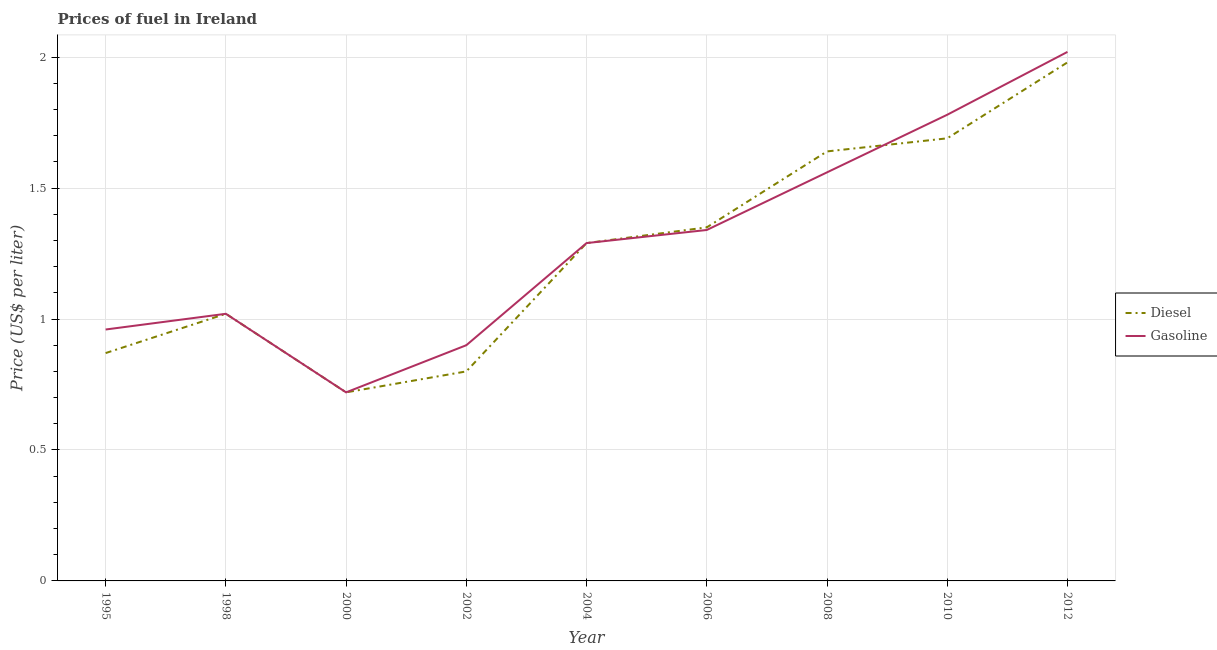What is the diesel price in 1998?
Offer a terse response. 1.02. Across all years, what is the maximum diesel price?
Provide a succinct answer. 1.98. Across all years, what is the minimum diesel price?
Your answer should be compact. 0.72. In which year was the diesel price maximum?
Give a very brief answer. 2012. In which year was the diesel price minimum?
Make the answer very short. 2000. What is the total gasoline price in the graph?
Your answer should be compact. 11.59. What is the difference between the diesel price in 1995 and that in 1998?
Ensure brevity in your answer.  -0.15. What is the difference between the diesel price in 2002 and the gasoline price in 1995?
Make the answer very short. -0.16. What is the average gasoline price per year?
Your answer should be compact. 1.29. In the year 1998, what is the difference between the diesel price and gasoline price?
Ensure brevity in your answer.  0. What is the ratio of the diesel price in 2006 to that in 2012?
Offer a terse response. 0.68. What is the difference between the highest and the second highest gasoline price?
Provide a succinct answer. 0.24. In how many years, is the gasoline price greater than the average gasoline price taken over all years?
Offer a terse response. 5. Does the gasoline price monotonically increase over the years?
Give a very brief answer. No. Is the gasoline price strictly less than the diesel price over the years?
Keep it short and to the point. No. How many years are there in the graph?
Offer a terse response. 9. Are the values on the major ticks of Y-axis written in scientific E-notation?
Your answer should be compact. No. How many legend labels are there?
Keep it short and to the point. 2. What is the title of the graph?
Offer a very short reply. Prices of fuel in Ireland. Does "National Visitors" appear as one of the legend labels in the graph?
Provide a succinct answer. No. What is the label or title of the Y-axis?
Keep it short and to the point. Price (US$ per liter). What is the Price (US$ per liter) in Diesel in 1995?
Provide a short and direct response. 0.87. What is the Price (US$ per liter) of Gasoline in 1995?
Keep it short and to the point. 0.96. What is the Price (US$ per liter) in Gasoline in 1998?
Provide a succinct answer. 1.02. What is the Price (US$ per liter) of Diesel in 2000?
Give a very brief answer. 0.72. What is the Price (US$ per liter) of Gasoline in 2000?
Keep it short and to the point. 0.72. What is the Price (US$ per liter) in Gasoline in 2002?
Give a very brief answer. 0.9. What is the Price (US$ per liter) of Diesel in 2004?
Offer a terse response. 1.29. What is the Price (US$ per liter) of Gasoline in 2004?
Give a very brief answer. 1.29. What is the Price (US$ per liter) of Diesel in 2006?
Your response must be concise. 1.35. What is the Price (US$ per liter) in Gasoline in 2006?
Offer a very short reply. 1.34. What is the Price (US$ per liter) in Diesel in 2008?
Offer a very short reply. 1.64. What is the Price (US$ per liter) in Gasoline in 2008?
Give a very brief answer. 1.56. What is the Price (US$ per liter) in Diesel in 2010?
Provide a succinct answer. 1.69. What is the Price (US$ per liter) in Gasoline in 2010?
Offer a terse response. 1.78. What is the Price (US$ per liter) of Diesel in 2012?
Keep it short and to the point. 1.98. What is the Price (US$ per liter) of Gasoline in 2012?
Your response must be concise. 2.02. Across all years, what is the maximum Price (US$ per liter) of Diesel?
Your response must be concise. 1.98. Across all years, what is the maximum Price (US$ per liter) in Gasoline?
Keep it short and to the point. 2.02. Across all years, what is the minimum Price (US$ per liter) of Diesel?
Offer a terse response. 0.72. Across all years, what is the minimum Price (US$ per liter) in Gasoline?
Give a very brief answer. 0.72. What is the total Price (US$ per liter) in Diesel in the graph?
Your response must be concise. 11.36. What is the total Price (US$ per liter) in Gasoline in the graph?
Your response must be concise. 11.59. What is the difference between the Price (US$ per liter) in Diesel in 1995 and that in 1998?
Make the answer very short. -0.15. What is the difference between the Price (US$ per liter) in Gasoline in 1995 and that in 1998?
Make the answer very short. -0.06. What is the difference between the Price (US$ per liter) of Gasoline in 1995 and that in 2000?
Offer a very short reply. 0.24. What is the difference between the Price (US$ per liter) in Diesel in 1995 and that in 2002?
Provide a short and direct response. 0.07. What is the difference between the Price (US$ per liter) in Diesel in 1995 and that in 2004?
Provide a succinct answer. -0.42. What is the difference between the Price (US$ per liter) of Gasoline in 1995 and that in 2004?
Give a very brief answer. -0.33. What is the difference between the Price (US$ per liter) of Diesel in 1995 and that in 2006?
Offer a terse response. -0.48. What is the difference between the Price (US$ per liter) in Gasoline in 1995 and that in 2006?
Make the answer very short. -0.38. What is the difference between the Price (US$ per liter) in Diesel in 1995 and that in 2008?
Give a very brief answer. -0.77. What is the difference between the Price (US$ per liter) of Gasoline in 1995 and that in 2008?
Provide a succinct answer. -0.6. What is the difference between the Price (US$ per liter) of Diesel in 1995 and that in 2010?
Your answer should be compact. -0.82. What is the difference between the Price (US$ per liter) of Gasoline in 1995 and that in 2010?
Give a very brief answer. -0.82. What is the difference between the Price (US$ per liter) in Diesel in 1995 and that in 2012?
Provide a succinct answer. -1.11. What is the difference between the Price (US$ per liter) of Gasoline in 1995 and that in 2012?
Offer a terse response. -1.06. What is the difference between the Price (US$ per liter) in Gasoline in 1998 and that in 2000?
Your answer should be compact. 0.3. What is the difference between the Price (US$ per liter) in Diesel in 1998 and that in 2002?
Provide a short and direct response. 0.22. What is the difference between the Price (US$ per liter) of Gasoline in 1998 and that in 2002?
Your response must be concise. 0.12. What is the difference between the Price (US$ per liter) in Diesel in 1998 and that in 2004?
Your answer should be compact. -0.27. What is the difference between the Price (US$ per liter) in Gasoline in 1998 and that in 2004?
Offer a terse response. -0.27. What is the difference between the Price (US$ per liter) in Diesel in 1998 and that in 2006?
Make the answer very short. -0.33. What is the difference between the Price (US$ per liter) in Gasoline in 1998 and that in 2006?
Make the answer very short. -0.32. What is the difference between the Price (US$ per liter) of Diesel in 1998 and that in 2008?
Offer a terse response. -0.62. What is the difference between the Price (US$ per liter) in Gasoline in 1998 and that in 2008?
Your answer should be very brief. -0.54. What is the difference between the Price (US$ per liter) of Diesel in 1998 and that in 2010?
Provide a succinct answer. -0.67. What is the difference between the Price (US$ per liter) of Gasoline in 1998 and that in 2010?
Offer a very short reply. -0.76. What is the difference between the Price (US$ per liter) of Diesel in 1998 and that in 2012?
Offer a terse response. -0.96. What is the difference between the Price (US$ per liter) in Gasoline in 1998 and that in 2012?
Provide a succinct answer. -1. What is the difference between the Price (US$ per liter) in Diesel in 2000 and that in 2002?
Offer a terse response. -0.08. What is the difference between the Price (US$ per liter) in Gasoline in 2000 and that in 2002?
Your response must be concise. -0.18. What is the difference between the Price (US$ per liter) in Diesel in 2000 and that in 2004?
Provide a short and direct response. -0.57. What is the difference between the Price (US$ per liter) in Gasoline in 2000 and that in 2004?
Your response must be concise. -0.57. What is the difference between the Price (US$ per liter) in Diesel in 2000 and that in 2006?
Offer a very short reply. -0.63. What is the difference between the Price (US$ per liter) in Gasoline in 2000 and that in 2006?
Make the answer very short. -0.62. What is the difference between the Price (US$ per liter) in Diesel in 2000 and that in 2008?
Your answer should be very brief. -0.92. What is the difference between the Price (US$ per liter) in Gasoline in 2000 and that in 2008?
Give a very brief answer. -0.84. What is the difference between the Price (US$ per liter) of Diesel in 2000 and that in 2010?
Your answer should be compact. -0.97. What is the difference between the Price (US$ per liter) of Gasoline in 2000 and that in 2010?
Your answer should be very brief. -1.06. What is the difference between the Price (US$ per liter) in Diesel in 2000 and that in 2012?
Your answer should be very brief. -1.26. What is the difference between the Price (US$ per liter) in Diesel in 2002 and that in 2004?
Your answer should be compact. -0.49. What is the difference between the Price (US$ per liter) in Gasoline in 2002 and that in 2004?
Provide a short and direct response. -0.39. What is the difference between the Price (US$ per liter) in Diesel in 2002 and that in 2006?
Your answer should be very brief. -0.55. What is the difference between the Price (US$ per liter) of Gasoline in 2002 and that in 2006?
Give a very brief answer. -0.44. What is the difference between the Price (US$ per liter) of Diesel in 2002 and that in 2008?
Make the answer very short. -0.84. What is the difference between the Price (US$ per liter) of Gasoline in 2002 and that in 2008?
Make the answer very short. -0.66. What is the difference between the Price (US$ per liter) in Diesel in 2002 and that in 2010?
Give a very brief answer. -0.89. What is the difference between the Price (US$ per liter) of Gasoline in 2002 and that in 2010?
Your answer should be very brief. -0.88. What is the difference between the Price (US$ per liter) of Diesel in 2002 and that in 2012?
Offer a very short reply. -1.18. What is the difference between the Price (US$ per liter) of Gasoline in 2002 and that in 2012?
Your answer should be compact. -1.12. What is the difference between the Price (US$ per liter) of Diesel in 2004 and that in 2006?
Make the answer very short. -0.06. What is the difference between the Price (US$ per liter) in Gasoline in 2004 and that in 2006?
Make the answer very short. -0.05. What is the difference between the Price (US$ per liter) in Diesel in 2004 and that in 2008?
Your answer should be very brief. -0.35. What is the difference between the Price (US$ per liter) in Gasoline in 2004 and that in 2008?
Make the answer very short. -0.27. What is the difference between the Price (US$ per liter) of Gasoline in 2004 and that in 2010?
Offer a very short reply. -0.49. What is the difference between the Price (US$ per liter) of Diesel in 2004 and that in 2012?
Your answer should be compact. -0.69. What is the difference between the Price (US$ per liter) in Gasoline in 2004 and that in 2012?
Your answer should be compact. -0.73. What is the difference between the Price (US$ per liter) in Diesel in 2006 and that in 2008?
Make the answer very short. -0.29. What is the difference between the Price (US$ per liter) in Gasoline in 2006 and that in 2008?
Your answer should be very brief. -0.22. What is the difference between the Price (US$ per liter) of Diesel in 2006 and that in 2010?
Provide a succinct answer. -0.34. What is the difference between the Price (US$ per liter) of Gasoline in 2006 and that in 2010?
Give a very brief answer. -0.44. What is the difference between the Price (US$ per liter) of Diesel in 2006 and that in 2012?
Ensure brevity in your answer.  -0.63. What is the difference between the Price (US$ per liter) of Gasoline in 2006 and that in 2012?
Provide a short and direct response. -0.68. What is the difference between the Price (US$ per liter) in Diesel in 2008 and that in 2010?
Give a very brief answer. -0.05. What is the difference between the Price (US$ per liter) in Gasoline in 2008 and that in 2010?
Offer a terse response. -0.22. What is the difference between the Price (US$ per liter) of Diesel in 2008 and that in 2012?
Provide a succinct answer. -0.34. What is the difference between the Price (US$ per liter) in Gasoline in 2008 and that in 2012?
Your answer should be compact. -0.46. What is the difference between the Price (US$ per liter) of Diesel in 2010 and that in 2012?
Your answer should be compact. -0.29. What is the difference between the Price (US$ per liter) in Gasoline in 2010 and that in 2012?
Keep it short and to the point. -0.24. What is the difference between the Price (US$ per liter) of Diesel in 1995 and the Price (US$ per liter) of Gasoline in 1998?
Ensure brevity in your answer.  -0.15. What is the difference between the Price (US$ per liter) of Diesel in 1995 and the Price (US$ per liter) of Gasoline in 2002?
Make the answer very short. -0.03. What is the difference between the Price (US$ per liter) in Diesel in 1995 and the Price (US$ per liter) in Gasoline in 2004?
Offer a very short reply. -0.42. What is the difference between the Price (US$ per liter) in Diesel in 1995 and the Price (US$ per liter) in Gasoline in 2006?
Keep it short and to the point. -0.47. What is the difference between the Price (US$ per liter) of Diesel in 1995 and the Price (US$ per liter) of Gasoline in 2008?
Make the answer very short. -0.69. What is the difference between the Price (US$ per liter) in Diesel in 1995 and the Price (US$ per liter) in Gasoline in 2010?
Ensure brevity in your answer.  -0.91. What is the difference between the Price (US$ per liter) of Diesel in 1995 and the Price (US$ per liter) of Gasoline in 2012?
Offer a very short reply. -1.15. What is the difference between the Price (US$ per liter) in Diesel in 1998 and the Price (US$ per liter) in Gasoline in 2002?
Offer a very short reply. 0.12. What is the difference between the Price (US$ per liter) in Diesel in 1998 and the Price (US$ per liter) in Gasoline in 2004?
Provide a short and direct response. -0.27. What is the difference between the Price (US$ per liter) in Diesel in 1998 and the Price (US$ per liter) in Gasoline in 2006?
Give a very brief answer. -0.32. What is the difference between the Price (US$ per liter) in Diesel in 1998 and the Price (US$ per liter) in Gasoline in 2008?
Offer a terse response. -0.54. What is the difference between the Price (US$ per liter) of Diesel in 1998 and the Price (US$ per liter) of Gasoline in 2010?
Your response must be concise. -0.76. What is the difference between the Price (US$ per liter) of Diesel in 1998 and the Price (US$ per liter) of Gasoline in 2012?
Offer a terse response. -1. What is the difference between the Price (US$ per liter) in Diesel in 2000 and the Price (US$ per liter) in Gasoline in 2002?
Provide a succinct answer. -0.18. What is the difference between the Price (US$ per liter) of Diesel in 2000 and the Price (US$ per liter) of Gasoline in 2004?
Your response must be concise. -0.57. What is the difference between the Price (US$ per liter) in Diesel in 2000 and the Price (US$ per liter) in Gasoline in 2006?
Offer a very short reply. -0.62. What is the difference between the Price (US$ per liter) in Diesel in 2000 and the Price (US$ per liter) in Gasoline in 2008?
Ensure brevity in your answer.  -0.84. What is the difference between the Price (US$ per liter) in Diesel in 2000 and the Price (US$ per liter) in Gasoline in 2010?
Provide a short and direct response. -1.06. What is the difference between the Price (US$ per liter) in Diesel in 2002 and the Price (US$ per liter) in Gasoline in 2004?
Give a very brief answer. -0.49. What is the difference between the Price (US$ per liter) of Diesel in 2002 and the Price (US$ per liter) of Gasoline in 2006?
Your answer should be compact. -0.54. What is the difference between the Price (US$ per liter) of Diesel in 2002 and the Price (US$ per liter) of Gasoline in 2008?
Keep it short and to the point. -0.76. What is the difference between the Price (US$ per liter) in Diesel in 2002 and the Price (US$ per liter) in Gasoline in 2010?
Ensure brevity in your answer.  -0.98. What is the difference between the Price (US$ per liter) in Diesel in 2002 and the Price (US$ per liter) in Gasoline in 2012?
Keep it short and to the point. -1.22. What is the difference between the Price (US$ per liter) of Diesel in 2004 and the Price (US$ per liter) of Gasoline in 2006?
Your response must be concise. -0.05. What is the difference between the Price (US$ per liter) of Diesel in 2004 and the Price (US$ per liter) of Gasoline in 2008?
Your response must be concise. -0.27. What is the difference between the Price (US$ per liter) of Diesel in 2004 and the Price (US$ per liter) of Gasoline in 2010?
Give a very brief answer. -0.49. What is the difference between the Price (US$ per liter) in Diesel in 2004 and the Price (US$ per liter) in Gasoline in 2012?
Offer a very short reply. -0.73. What is the difference between the Price (US$ per liter) of Diesel in 2006 and the Price (US$ per liter) of Gasoline in 2008?
Offer a very short reply. -0.21. What is the difference between the Price (US$ per liter) in Diesel in 2006 and the Price (US$ per liter) in Gasoline in 2010?
Your answer should be very brief. -0.43. What is the difference between the Price (US$ per liter) in Diesel in 2006 and the Price (US$ per liter) in Gasoline in 2012?
Keep it short and to the point. -0.67. What is the difference between the Price (US$ per liter) in Diesel in 2008 and the Price (US$ per liter) in Gasoline in 2010?
Keep it short and to the point. -0.14. What is the difference between the Price (US$ per liter) in Diesel in 2008 and the Price (US$ per liter) in Gasoline in 2012?
Offer a terse response. -0.38. What is the difference between the Price (US$ per liter) in Diesel in 2010 and the Price (US$ per liter) in Gasoline in 2012?
Ensure brevity in your answer.  -0.33. What is the average Price (US$ per liter) of Diesel per year?
Provide a short and direct response. 1.26. What is the average Price (US$ per liter) of Gasoline per year?
Provide a succinct answer. 1.29. In the year 1995, what is the difference between the Price (US$ per liter) of Diesel and Price (US$ per liter) of Gasoline?
Provide a succinct answer. -0.09. In the year 2000, what is the difference between the Price (US$ per liter) of Diesel and Price (US$ per liter) of Gasoline?
Ensure brevity in your answer.  0. In the year 2006, what is the difference between the Price (US$ per liter) in Diesel and Price (US$ per liter) in Gasoline?
Keep it short and to the point. 0.01. In the year 2010, what is the difference between the Price (US$ per liter) in Diesel and Price (US$ per liter) in Gasoline?
Offer a very short reply. -0.09. In the year 2012, what is the difference between the Price (US$ per liter) of Diesel and Price (US$ per liter) of Gasoline?
Make the answer very short. -0.04. What is the ratio of the Price (US$ per liter) in Diesel in 1995 to that in 1998?
Offer a very short reply. 0.85. What is the ratio of the Price (US$ per liter) of Diesel in 1995 to that in 2000?
Keep it short and to the point. 1.21. What is the ratio of the Price (US$ per liter) in Gasoline in 1995 to that in 2000?
Keep it short and to the point. 1.33. What is the ratio of the Price (US$ per liter) in Diesel in 1995 to that in 2002?
Your response must be concise. 1.09. What is the ratio of the Price (US$ per liter) of Gasoline in 1995 to that in 2002?
Your answer should be compact. 1.07. What is the ratio of the Price (US$ per liter) in Diesel in 1995 to that in 2004?
Provide a succinct answer. 0.67. What is the ratio of the Price (US$ per liter) of Gasoline in 1995 to that in 2004?
Make the answer very short. 0.74. What is the ratio of the Price (US$ per liter) of Diesel in 1995 to that in 2006?
Your answer should be very brief. 0.64. What is the ratio of the Price (US$ per liter) of Gasoline in 1995 to that in 2006?
Keep it short and to the point. 0.72. What is the ratio of the Price (US$ per liter) of Diesel in 1995 to that in 2008?
Your response must be concise. 0.53. What is the ratio of the Price (US$ per liter) in Gasoline in 1995 to that in 2008?
Give a very brief answer. 0.62. What is the ratio of the Price (US$ per liter) in Diesel in 1995 to that in 2010?
Offer a very short reply. 0.51. What is the ratio of the Price (US$ per liter) in Gasoline in 1995 to that in 2010?
Keep it short and to the point. 0.54. What is the ratio of the Price (US$ per liter) of Diesel in 1995 to that in 2012?
Your answer should be compact. 0.44. What is the ratio of the Price (US$ per liter) in Gasoline in 1995 to that in 2012?
Your answer should be compact. 0.48. What is the ratio of the Price (US$ per liter) in Diesel in 1998 to that in 2000?
Ensure brevity in your answer.  1.42. What is the ratio of the Price (US$ per liter) in Gasoline in 1998 to that in 2000?
Your response must be concise. 1.42. What is the ratio of the Price (US$ per liter) of Diesel in 1998 to that in 2002?
Your answer should be compact. 1.27. What is the ratio of the Price (US$ per liter) in Gasoline in 1998 to that in 2002?
Give a very brief answer. 1.13. What is the ratio of the Price (US$ per liter) of Diesel in 1998 to that in 2004?
Provide a succinct answer. 0.79. What is the ratio of the Price (US$ per liter) of Gasoline in 1998 to that in 2004?
Offer a terse response. 0.79. What is the ratio of the Price (US$ per liter) in Diesel in 1998 to that in 2006?
Offer a very short reply. 0.76. What is the ratio of the Price (US$ per liter) in Gasoline in 1998 to that in 2006?
Make the answer very short. 0.76. What is the ratio of the Price (US$ per liter) of Diesel in 1998 to that in 2008?
Your response must be concise. 0.62. What is the ratio of the Price (US$ per liter) in Gasoline in 1998 to that in 2008?
Your answer should be very brief. 0.65. What is the ratio of the Price (US$ per liter) in Diesel in 1998 to that in 2010?
Offer a very short reply. 0.6. What is the ratio of the Price (US$ per liter) in Gasoline in 1998 to that in 2010?
Offer a very short reply. 0.57. What is the ratio of the Price (US$ per liter) in Diesel in 1998 to that in 2012?
Your answer should be compact. 0.52. What is the ratio of the Price (US$ per liter) in Gasoline in 1998 to that in 2012?
Make the answer very short. 0.51. What is the ratio of the Price (US$ per liter) in Diesel in 2000 to that in 2002?
Offer a very short reply. 0.9. What is the ratio of the Price (US$ per liter) of Gasoline in 2000 to that in 2002?
Ensure brevity in your answer.  0.8. What is the ratio of the Price (US$ per liter) in Diesel in 2000 to that in 2004?
Provide a succinct answer. 0.56. What is the ratio of the Price (US$ per liter) in Gasoline in 2000 to that in 2004?
Ensure brevity in your answer.  0.56. What is the ratio of the Price (US$ per liter) in Diesel in 2000 to that in 2006?
Give a very brief answer. 0.53. What is the ratio of the Price (US$ per liter) in Gasoline in 2000 to that in 2006?
Your answer should be compact. 0.54. What is the ratio of the Price (US$ per liter) of Diesel in 2000 to that in 2008?
Provide a short and direct response. 0.44. What is the ratio of the Price (US$ per liter) in Gasoline in 2000 to that in 2008?
Your answer should be compact. 0.46. What is the ratio of the Price (US$ per liter) in Diesel in 2000 to that in 2010?
Your response must be concise. 0.43. What is the ratio of the Price (US$ per liter) in Gasoline in 2000 to that in 2010?
Offer a very short reply. 0.4. What is the ratio of the Price (US$ per liter) in Diesel in 2000 to that in 2012?
Offer a terse response. 0.36. What is the ratio of the Price (US$ per liter) of Gasoline in 2000 to that in 2012?
Your answer should be compact. 0.36. What is the ratio of the Price (US$ per liter) of Diesel in 2002 to that in 2004?
Your answer should be very brief. 0.62. What is the ratio of the Price (US$ per liter) of Gasoline in 2002 to that in 2004?
Offer a very short reply. 0.7. What is the ratio of the Price (US$ per liter) in Diesel in 2002 to that in 2006?
Provide a succinct answer. 0.59. What is the ratio of the Price (US$ per liter) in Gasoline in 2002 to that in 2006?
Offer a terse response. 0.67. What is the ratio of the Price (US$ per liter) in Diesel in 2002 to that in 2008?
Provide a succinct answer. 0.49. What is the ratio of the Price (US$ per liter) of Gasoline in 2002 to that in 2008?
Your response must be concise. 0.58. What is the ratio of the Price (US$ per liter) of Diesel in 2002 to that in 2010?
Give a very brief answer. 0.47. What is the ratio of the Price (US$ per liter) in Gasoline in 2002 to that in 2010?
Keep it short and to the point. 0.51. What is the ratio of the Price (US$ per liter) in Diesel in 2002 to that in 2012?
Your answer should be compact. 0.4. What is the ratio of the Price (US$ per liter) of Gasoline in 2002 to that in 2012?
Give a very brief answer. 0.45. What is the ratio of the Price (US$ per liter) in Diesel in 2004 to that in 2006?
Your answer should be compact. 0.96. What is the ratio of the Price (US$ per liter) in Gasoline in 2004 to that in 2006?
Your answer should be compact. 0.96. What is the ratio of the Price (US$ per liter) of Diesel in 2004 to that in 2008?
Offer a very short reply. 0.79. What is the ratio of the Price (US$ per liter) in Gasoline in 2004 to that in 2008?
Ensure brevity in your answer.  0.83. What is the ratio of the Price (US$ per liter) of Diesel in 2004 to that in 2010?
Provide a succinct answer. 0.76. What is the ratio of the Price (US$ per liter) in Gasoline in 2004 to that in 2010?
Provide a succinct answer. 0.72. What is the ratio of the Price (US$ per liter) in Diesel in 2004 to that in 2012?
Keep it short and to the point. 0.65. What is the ratio of the Price (US$ per liter) in Gasoline in 2004 to that in 2012?
Your answer should be very brief. 0.64. What is the ratio of the Price (US$ per liter) of Diesel in 2006 to that in 2008?
Offer a terse response. 0.82. What is the ratio of the Price (US$ per liter) of Gasoline in 2006 to that in 2008?
Provide a short and direct response. 0.86. What is the ratio of the Price (US$ per liter) in Diesel in 2006 to that in 2010?
Offer a very short reply. 0.8. What is the ratio of the Price (US$ per liter) of Gasoline in 2006 to that in 2010?
Your response must be concise. 0.75. What is the ratio of the Price (US$ per liter) in Diesel in 2006 to that in 2012?
Keep it short and to the point. 0.68. What is the ratio of the Price (US$ per liter) in Gasoline in 2006 to that in 2012?
Your answer should be compact. 0.66. What is the ratio of the Price (US$ per liter) of Diesel in 2008 to that in 2010?
Your answer should be compact. 0.97. What is the ratio of the Price (US$ per liter) in Gasoline in 2008 to that in 2010?
Your answer should be very brief. 0.88. What is the ratio of the Price (US$ per liter) of Diesel in 2008 to that in 2012?
Offer a terse response. 0.83. What is the ratio of the Price (US$ per liter) of Gasoline in 2008 to that in 2012?
Make the answer very short. 0.77. What is the ratio of the Price (US$ per liter) of Diesel in 2010 to that in 2012?
Your answer should be very brief. 0.85. What is the ratio of the Price (US$ per liter) of Gasoline in 2010 to that in 2012?
Your answer should be compact. 0.88. What is the difference between the highest and the second highest Price (US$ per liter) in Diesel?
Provide a short and direct response. 0.29. What is the difference between the highest and the second highest Price (US$ per liter) of Gasoline?
Offer a very short reply. 0.24. What is the difference between the highest and the lowest Price (US$ per liter) of Diesel?
Offer a very short reply. 1.26. What is the difference between the highest and the lowest Price (US$ per liter) in Gasoline?
Offer a terse response. 1.3. 